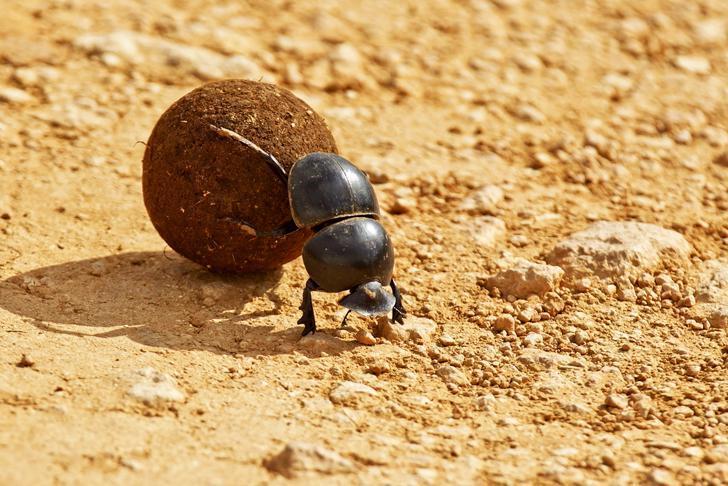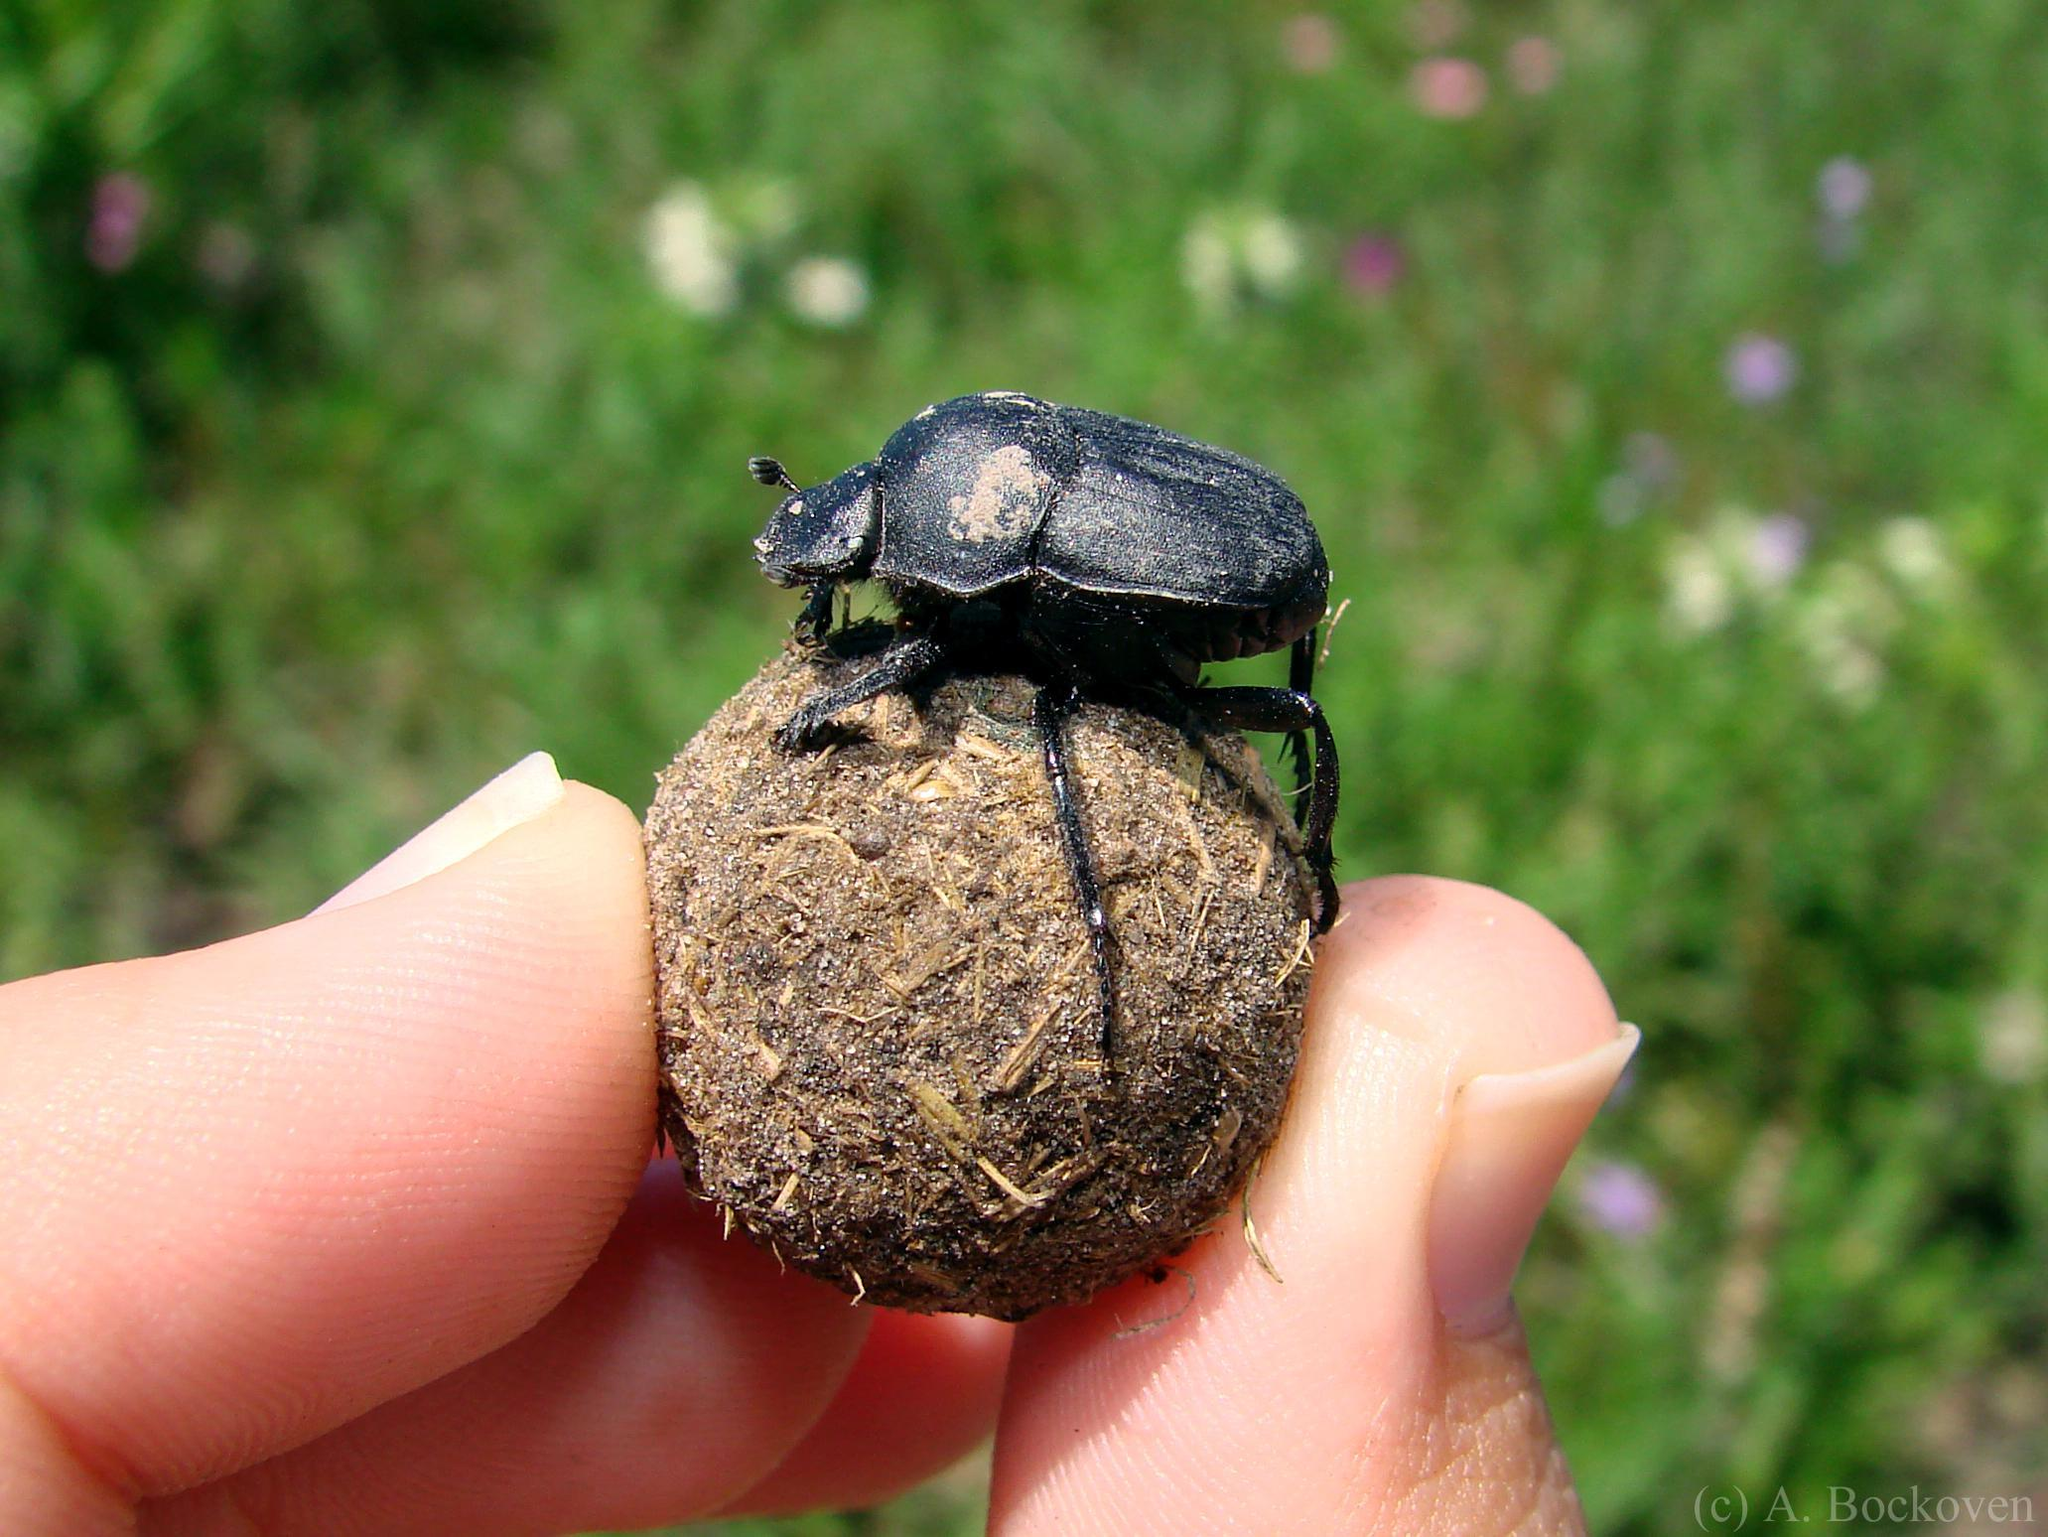The first image is the image on the left, the second image is the image on the right. For the images shown, is this caption "The right image contains a human hand interacting with a dung beetle." true? Answer yes or no. Yes. The first image is the image on the left, the second image is the image on the right. Considering the images on both sides, is "An image of a beetle includes a thumb and fingers." valid? Answer yes or no. Yes. 